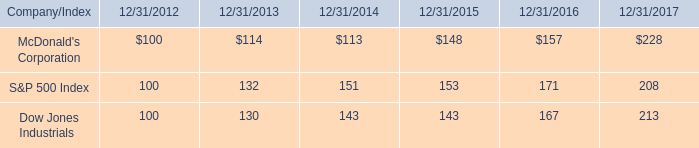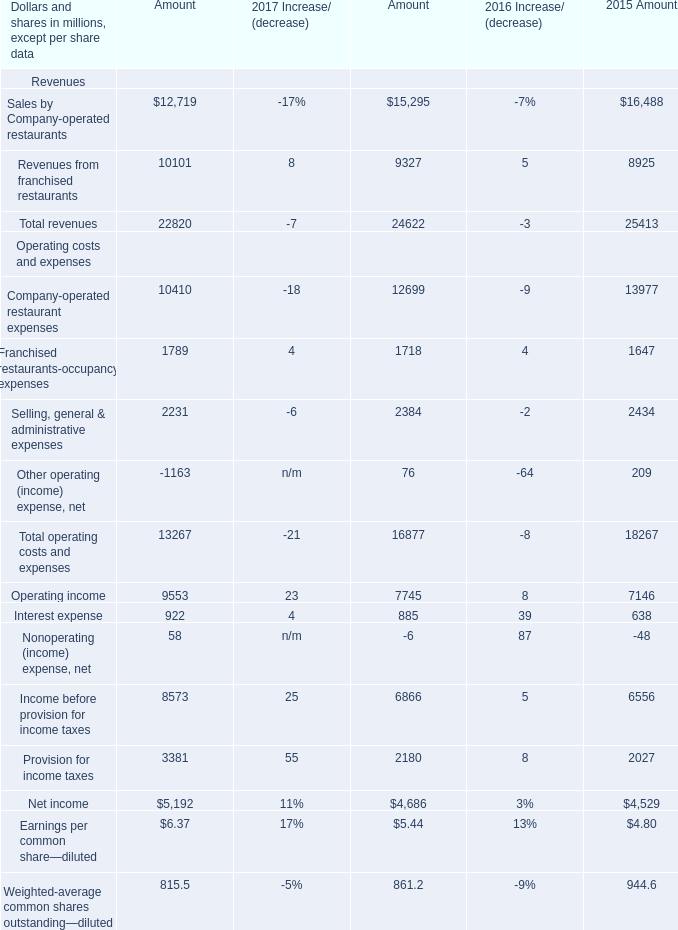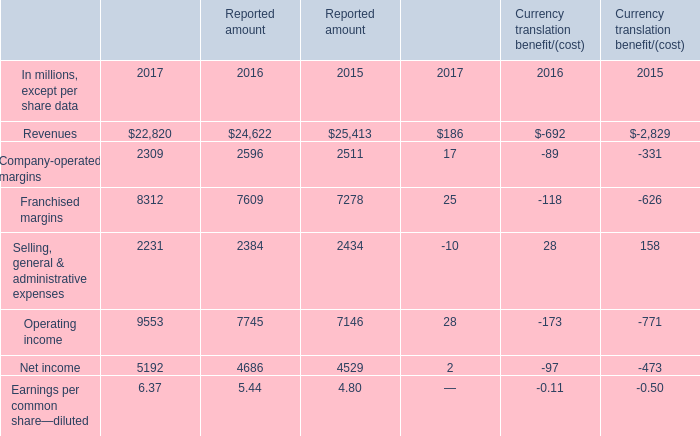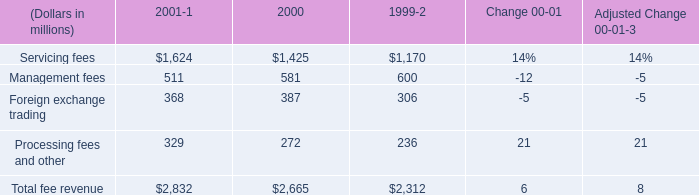What was the total amount of the Franchised margins in the years where Selling, general & administrative expenses greater than 0? (in million) 
Computations: (((((8312 + 7609) + 7278) + 25) - 118) - 626)
Answer: 22480.0. 